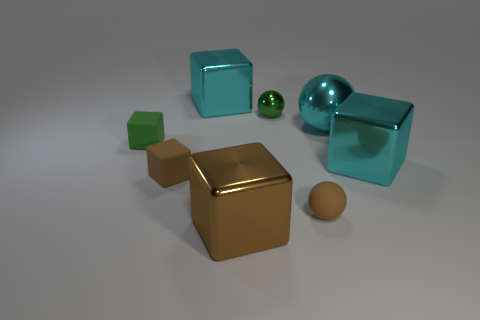Subtract all large brown blocks. How many blocks are left? 4 Subtract all green blocks. How many blocks are left? 4 Subtract all yellow cubes. Subtract all blue cylinders. How many cubes are left? 5 Add 2 tiny yellow metallic blocks. How many objects exist? 10 Subtract all spheres. How many objects are left? 5 Add 5 metal balls. How many metal balls are left? 7 Add 7 red objects. How many red objects exist? 7 Subtract 0 yellow cylinders. How many objects are left? 8 Subtract all brown objects. Subtract all rubber spheres. How many objects are left? 4 